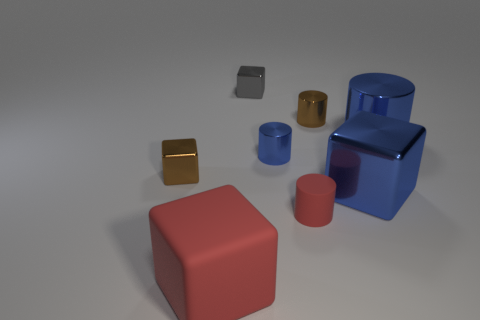Subtract 1 cylinders. How many cylinders are left? 3 Subtract all purple cubes. Subtract all brown spheres. How many cubes are left? 4 Add 1 blue cylinders. How many objects exist? 9 Add 2 gray cubes. How many gray cubes are left? 3 Add 7 blue metallic cylinders. How many blue metallic cylinders exist? 9 Subtract 0 green cylinders. How many objects are left? 8 Subtract all brown things. Subtract all small metal blocks. How many objects are left? 4 